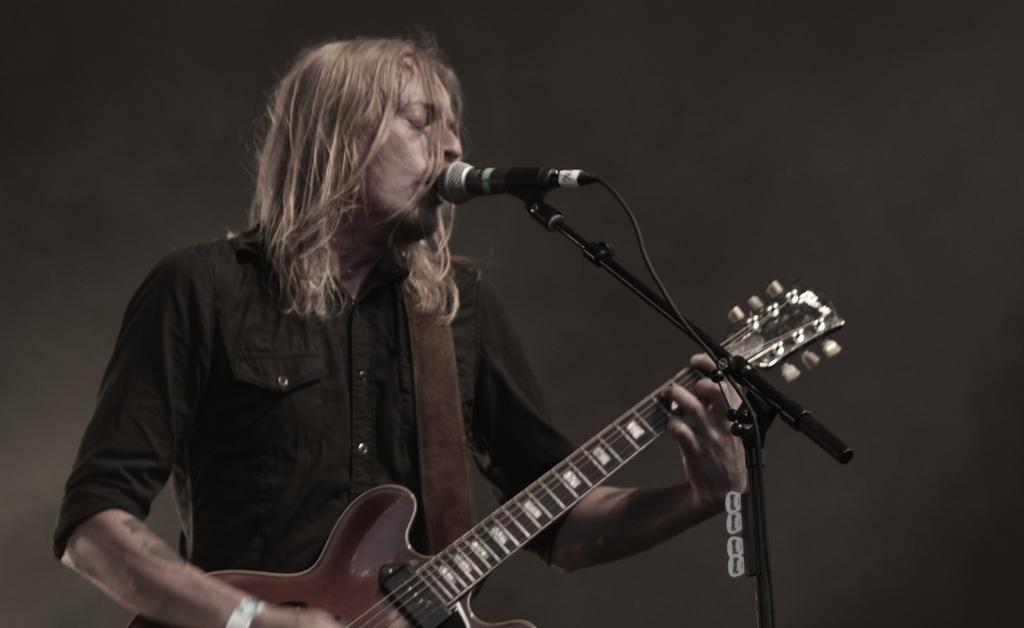What is the man in the image holding? The man is holding a guitar. How is the man holding the guitar? The man is using his hands to hold the guitar. What is in front of the man in the image? There is a microphone (mic) in front of the man. Can you describe the background of the image? The background of the image is blurry. What type of cloth is the man using to cover the frog in the image? There is no frog or cloth present in the image; it features a man holding a guitar with a microphone in front of him. 